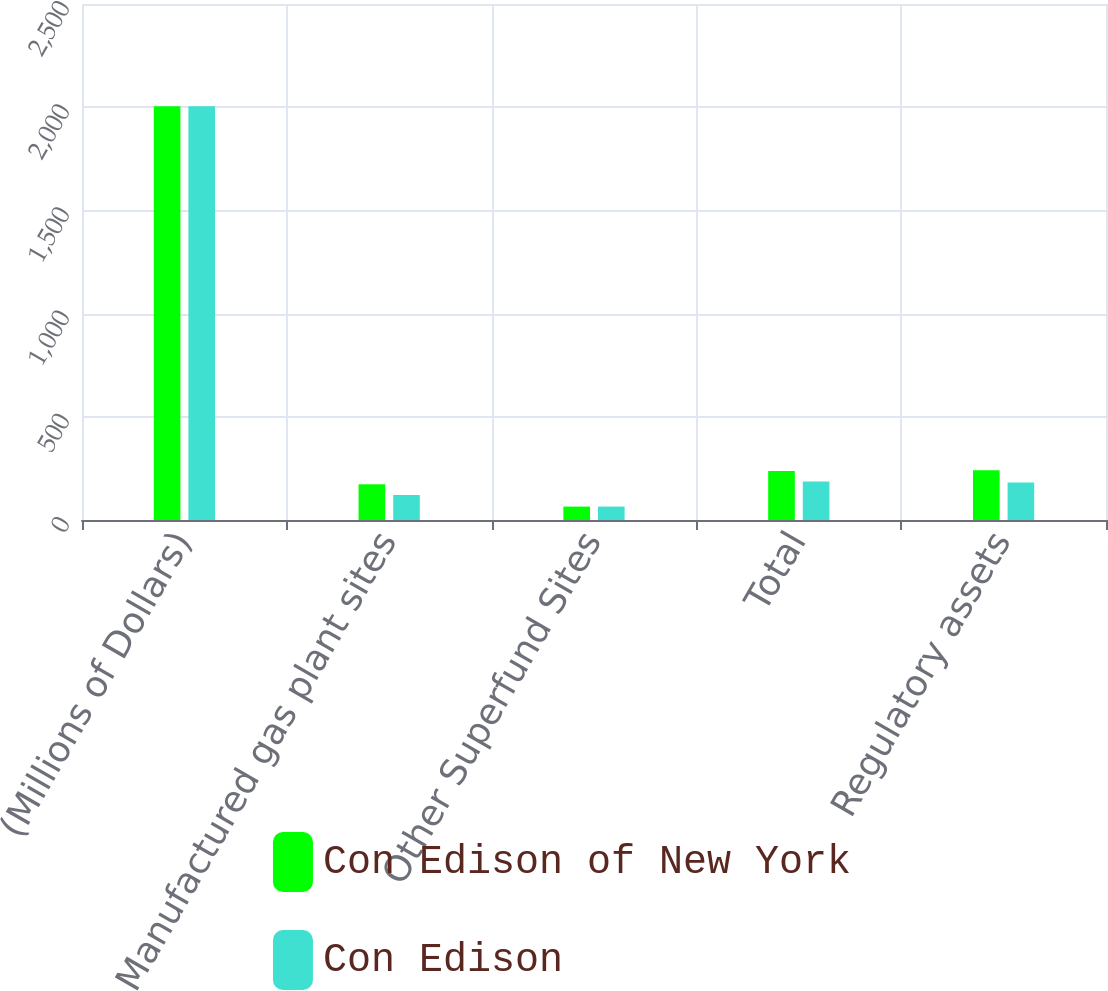Convert chart. <chart><loc_0><loc_0><loc_500><loc_500><stacked_bar_chart><ecel><fcel>(Millions of Dollars)<fcel>Manufactured gas plant sites<fcel>Other Superfund Sites<fcel>Total<fcel>Regulatory assets<nl><fcel>Con Edison of New York<fcel>2005<fcel>173<fcel>65<fcel>238<fcel>241<nl><fcel>Con Edison<fcel>2005<fcel>121<fcel>65<fcel>186<fcel>182<nl></chart> 